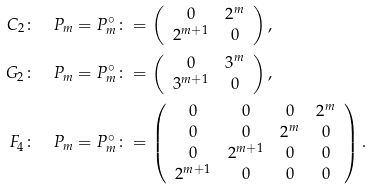<formula> <loc_0><loc_0><loc_500><loc_500>C _ { 2 } & \colon \quad P _ { m } = P _ { m } ^ { \circ } \colon = \left ( \begin{array} { c c } 0 & 2 ^ { m } \\ 2 ^ { m + 1 } & 0 \end{array} \right ) , \\ G _ { 2 } & \colon \quad P _ { m } = P _ { m } ^ { \circ } \colon = \left ( \begin{array} { c c } 0 & 3 ^ { m } \\ 3 ^ { m + 1 } & 0 \end{array} \right ) , \\ F _ { 4 } & \colon \quad P _ { m } = P _ { m } ^ { \circ } \colon = \left ( \begin{array} { c c c c } 0 & 0 & 0 & 2 ^ { m } \\ 0 & 0 & 2 ^ { m } & 0 \\ 0 & 2 ^ { m + 1 } & 0 & 0 \\ 2 ^ { m + 1 } & 0 & 0 & 0 \end{array} \right ) .</formula> 